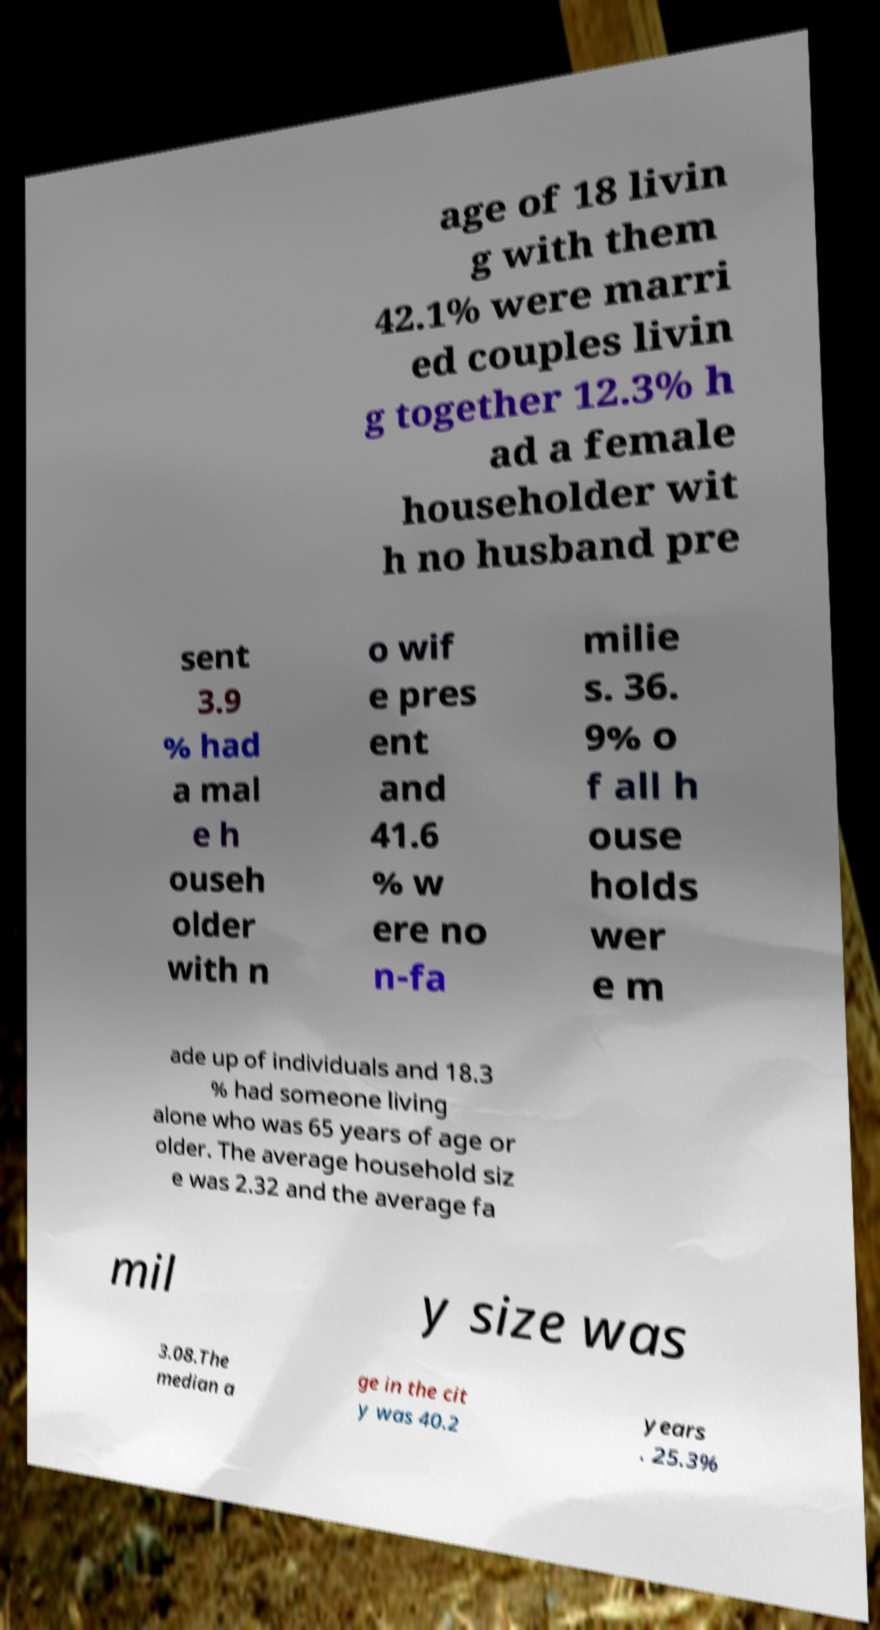Please read and relay the text visible in this image. What does it say? age of 18 livin g with them 42.1% were marri ed couples livin g together 12.3% h ad a female householder wit h no husband pre sent 3.9 % had a mal e h ouseh older with n o wif e pres ent and 41.6 % w ere no n-fa milie s. 36. 9% o f all h ouse holds wer e m ade up of individuals and 18.3 % had someone living alone who was 65 years of age or older. The average household siz e was 2.32 and the average fa mil y size was 3.08.The median a ge in the cit y was 40.2 years . 25.3% 